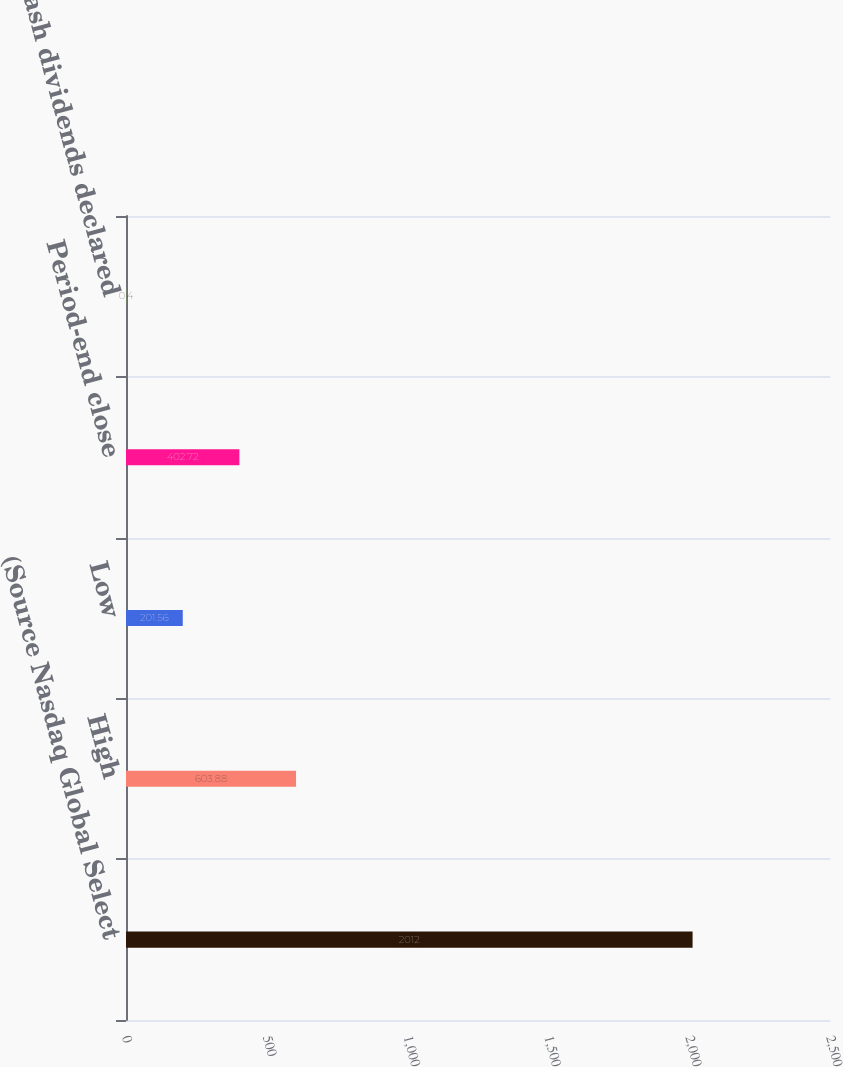Convert chart to OTSL. <chart><loc_0><loc_0><loc_500><loc_500><bar_chart><fcel>(Source Nasdaq Global Select<fcel>High<fcel>Low<fcel>Period-end close<fcel>Cash dividends declared<nl><fcel>2012<fcel>603.88<fcel>201.56<fcel>402.72<fcel>0.4<nl></chart> 